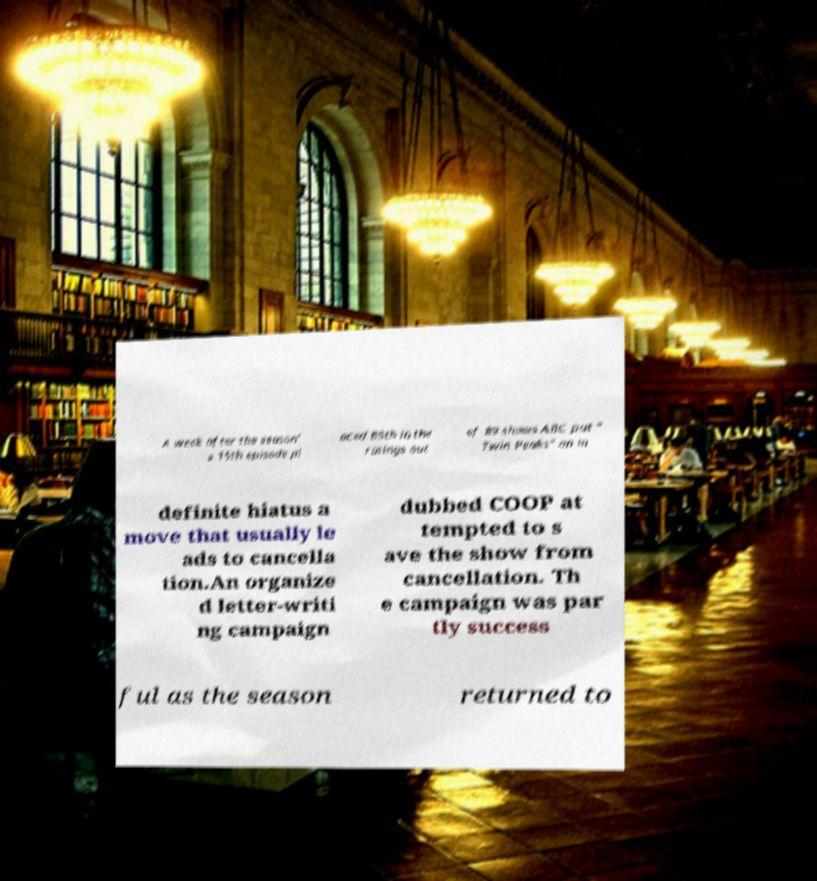Can you read and provide the text displayed in the image?This photo seems to have some interesting text. Can you extract and type it out for me? A week after the season' s 15th episode pl aced 85th in the ratings out of 89 shows ABC put " Twin Peaks" on in definite hiatus a move that usually le ads to cancella tion.An organize d letter-writi ng campaign dubbed COOP at tempted to s ave the show from cancellation. Th e campaign was par tly success ful as the season returned to 